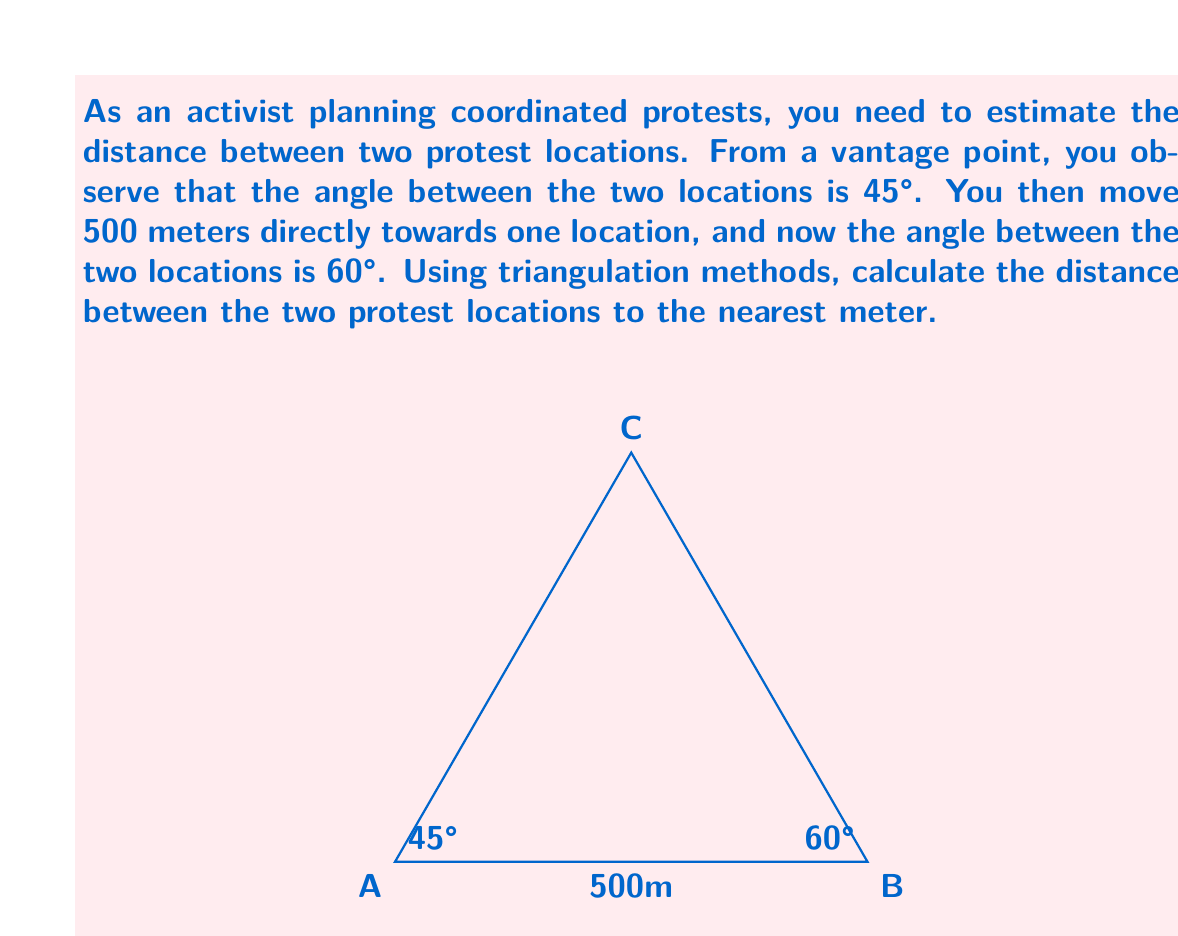Could you help me with this problem? Let's approach this step-by-step using the law of sines:

1) Let's denote the two protest locations as A and C, and your initial position as B.

2) In triangle ABC:
   $\angle BAC = 45°$
   $\angle ABC = 60°$
   $\angle BCA = 180° - 45° - 60° = 75°$

3) We know that $AB = 500$ meters.

4) Using the law of sines:
   $$\frac{AC}{\sin 60°} = \frac{500}{\sin 75°}$$

5) Solving for AC:
   $$AC = \frac{500 \cdot \sin 60°}{\sin 75°}$$

6) Calculate:
   $$AC = \frac{500 \cdot \frac{\sqrt{3}}{2}}{\frac{\sqrt{6}+\sqrt{2}}{4}}$$

7) Simplify:
   $$AC = \frac{500 \cdot \sqrt{3} \cdot 4}{\sqrt{6}+\sqrt{2}} \approx 866.03$$

8) Rounding to the nearest meter:
   $AC \approx 866$ meters

Therefore, the distance between the two protest locations is approximately 866 meters.
Answer: 866 meters 